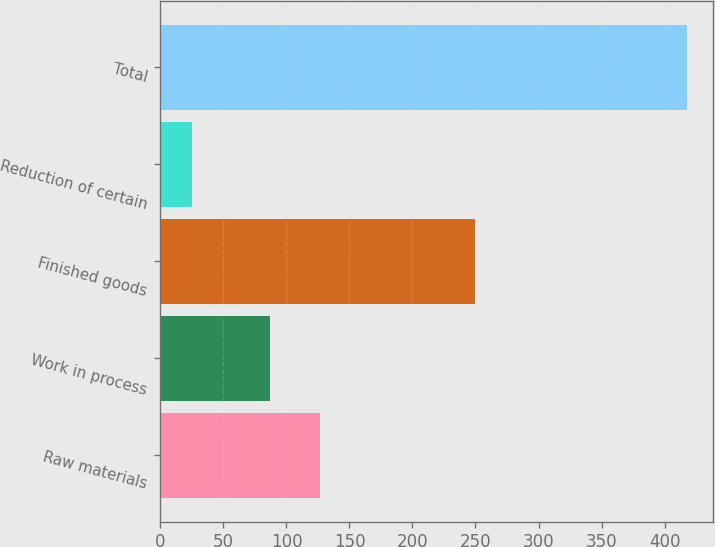Convert chart. <chart><loc_0><loc_0><loc_500><loc_500><bar_chart><fcel>Raw materials<fcel>Work in process<fcel>Finished goods<fcel>Reduction of certain<fcel>Total<nl><fcel>126.5<fcel>87.2<fcel>249.5<fcel>24.9<fcel>417.9<nl></chart> 